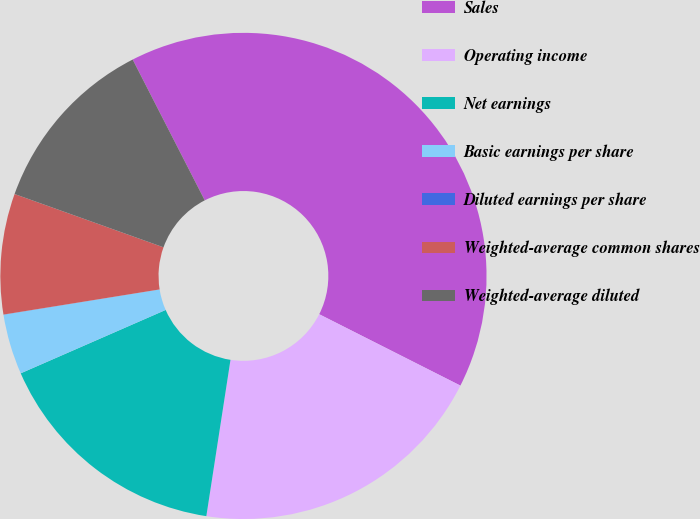Convert chart to OTSL. <chart><loc_0><loc_0><loc_500><loc_500><pie_chart><fcel>Sales<fcel>Operating income<fcel>Net earnings<fcel>Basic earnings per share<fcel>Diluted earnings per share<fcel>Weighted-average common shares<fcel>Weighted-average diluted<nl><fcel>39.98%<fcel>19.99%<fcel>16.0%<fcel>4.01%<fcel>0.01%<fcel>8.01%<fcel>12.0%<nl></chart> 